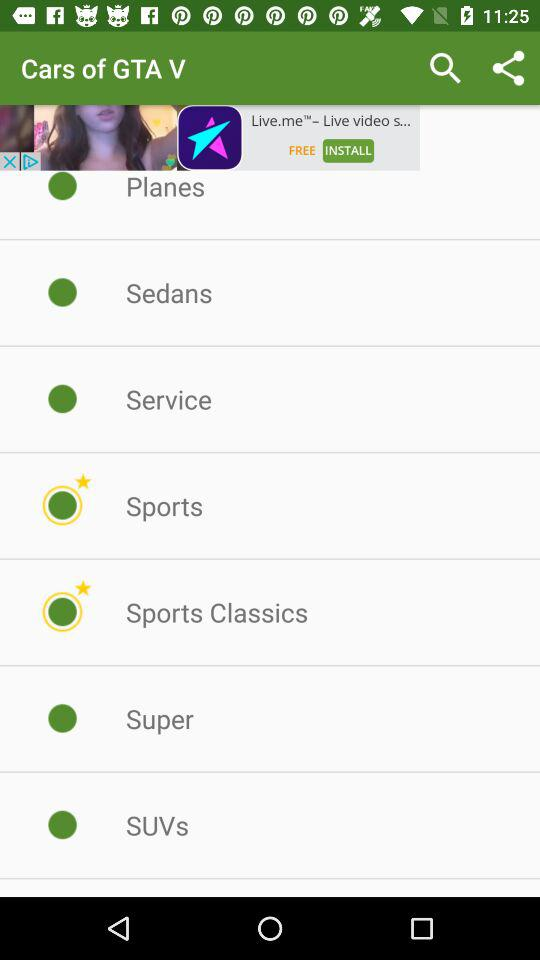Which cars are marked with stars? The cars are "Sports" and "Sports Classics". 